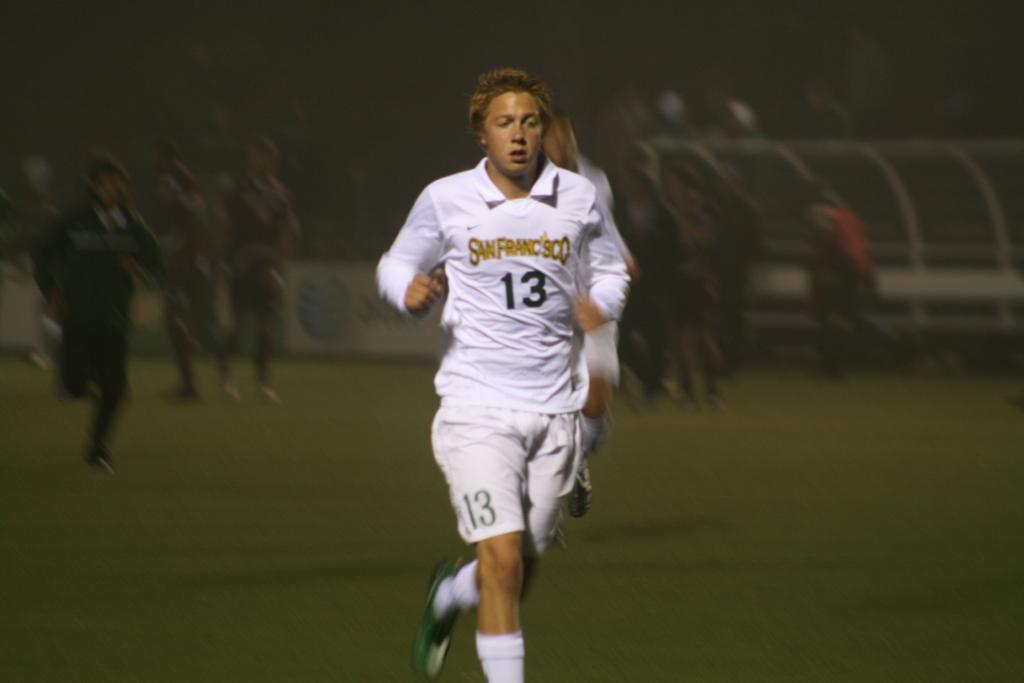What is the jersey number of the player in white?
Give a very brief answer. 13. 